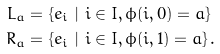<formula> <loc_0><loc_0><loc_500><loc_500>L _ { a } = & \ \{ e _ { i } \ | \ i \in I , \phi ( i , 0 ) = a \} \\ R _ { a } = & \ \{ e _ { i } \ | \ i \in I , \phi ( i , 1 ) = a \} \, .</formula> 